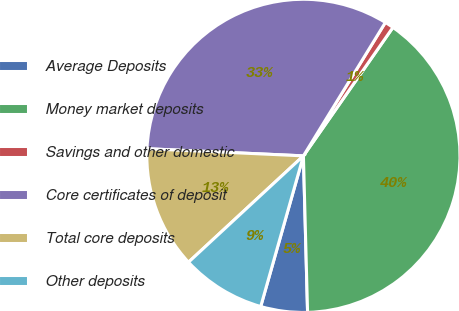Convert chart to OTSL. <chart><loc_0><loc_0><loc_500><loc_500><pie_chart><fcel>Average Deposits<fcel>Money market deposits<fcel>Savings and other domestic<fcel>Core certificates of deposit<fcel>Total core deposits<fcel>Other deposits<nl><fcel>4.82%<fcel>39.89%<fcel>0.92%<fcel>33.04%<fcel>12.61%<fcel>8.72%<nl></chart> 